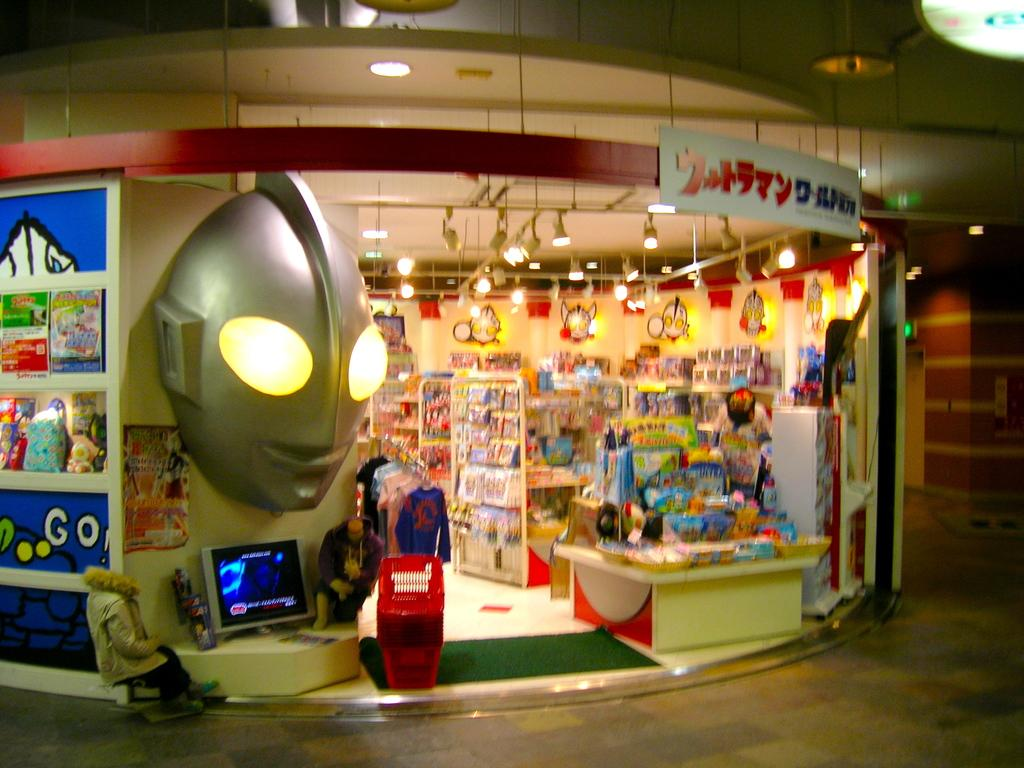Provide a one-sentence caption for the provided image. A Japanese shop with the English word Go! written on the sign outside. 